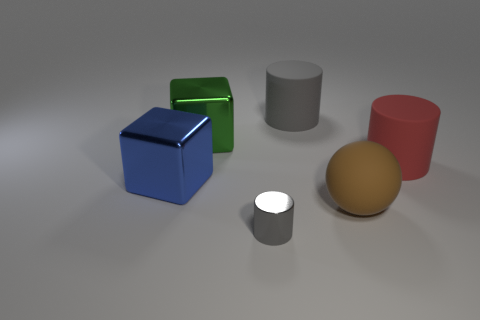Subtract all tiny gray shiny cylinders. How many cylinders are left? 2 Subtract all yellow balls. How many gray cylinders are left? 2 Add 1 gray spheres. How many objects exist? 7 Subtract all spheres. How many objects are left? 5 Subtract all green cylinders. Subtract all brown cubes. How many cylinders are left? 3 Subtract 0 purple balls. How many objects are left? 6 Subtract all large brown rubber objects. Subtract all red matte things. How many objects are left? 4 Add 4 large gray rubber things. How many large gray rubber things are left? 5 Add 6 brown rubber objects. How many brown rubber objects exist? 7 